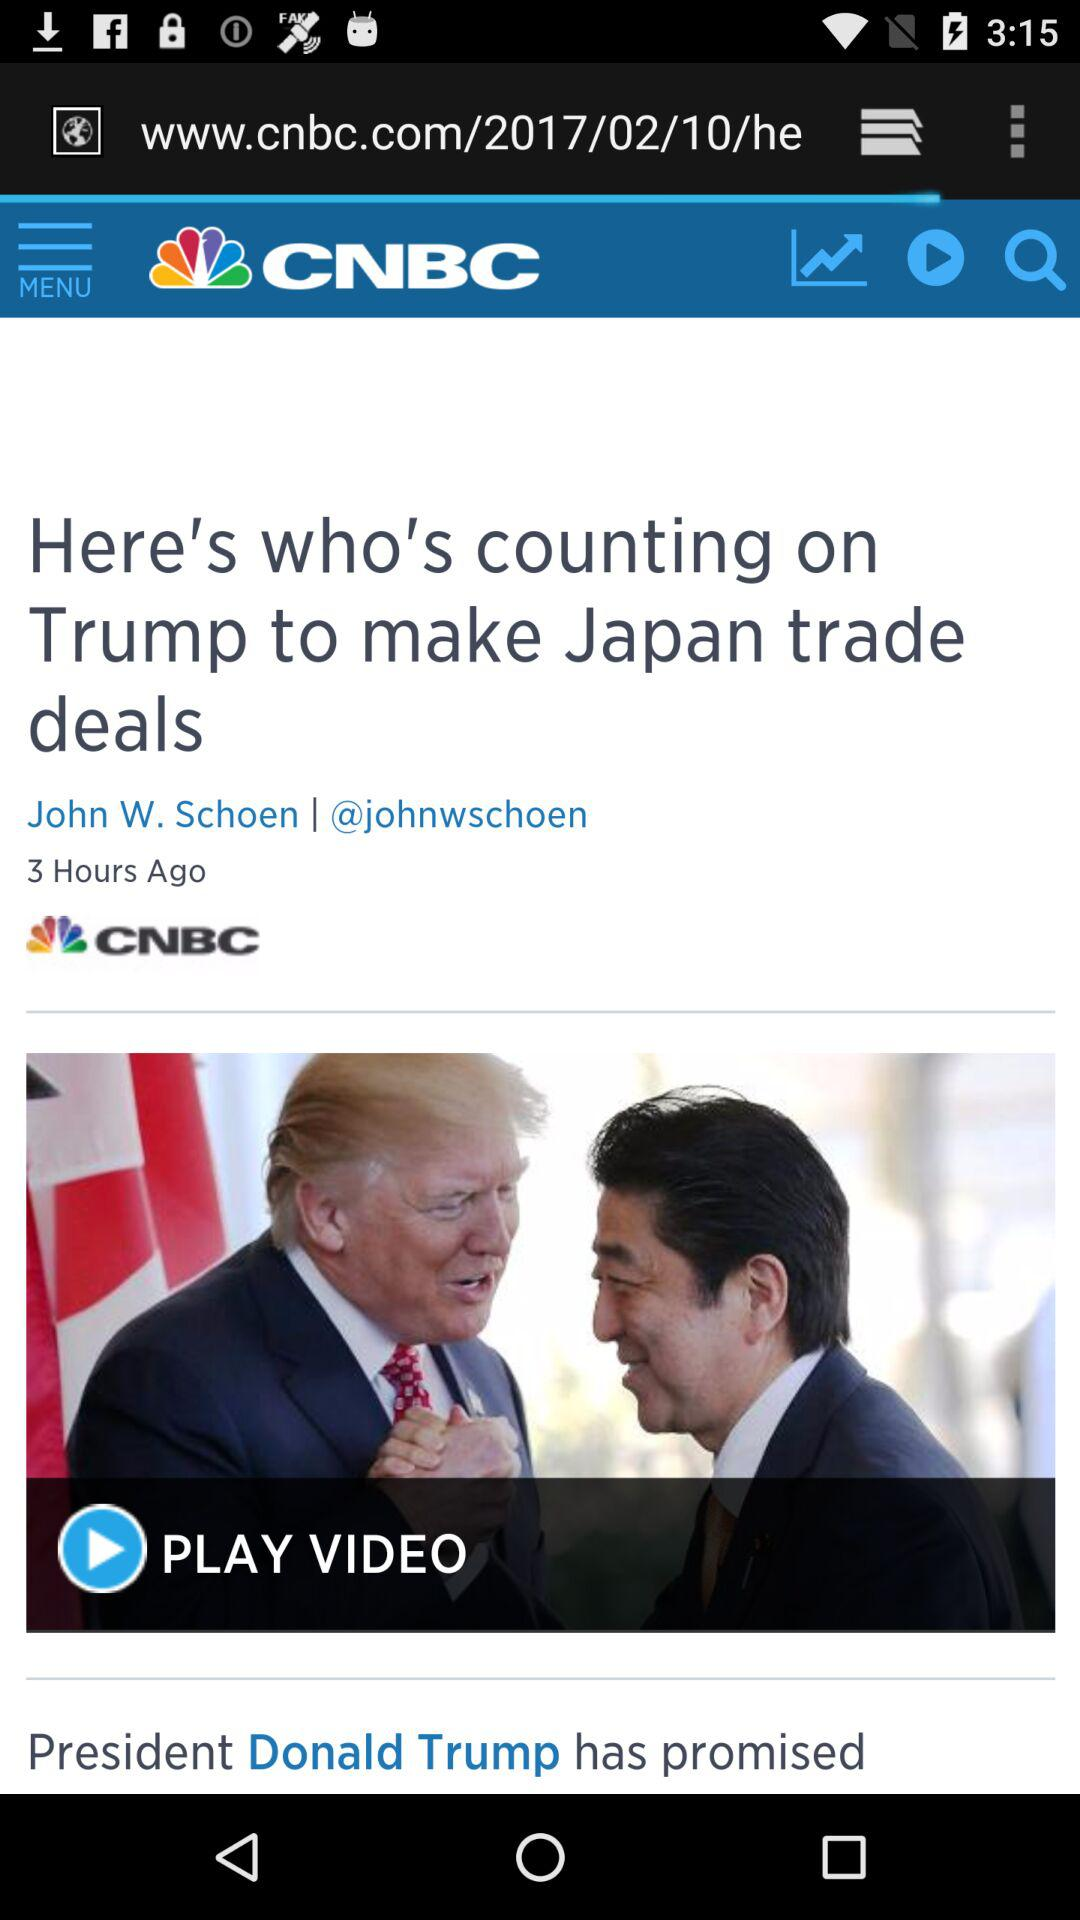What is the username of the author? The username of the author is "@johnwschoen". 